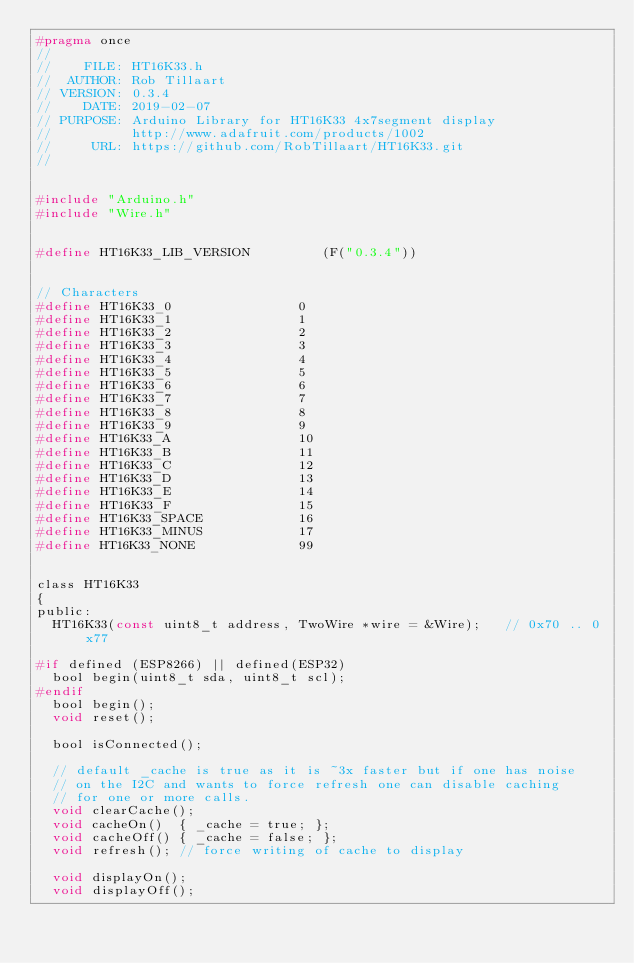Convert code to text. <code><loc_0><loc_0><loc_500><loc_500><_C_>#pragma once
//
//    FILE: HT16K33.h
//  AUTHOR: Rob Tillaart
// VERSION: 0.3.4
//    DATE: 2019-02-07
// PURPOSE: Arduino Library for HT16K33 4x7segment display
//          http://www.adafruit.com/products/1002
//     URL: https://github.com/RobTillaart/HT16K33.git
//


#include "Arduino.h"
#include "Wire.h"


#define HT16K33_LIB_VERSION         (F("0.3.4"))


// Characters
#define HT16K33_0                0
#define HT16K33_1                1
#define HT16K33_2                2
#define HT16K33_3                3
#define HT16K33_4                4
#define HT16K33_5                5
#define HT16K33_6                6
#define HT16K33_7                7
#define HT16K33_8                8
#define HT16K33_9                9
#define HT16K33_A                10
#define HT16K33_B                11
#define HT16K33_C                12
#define HT16K33_D                13
#define HT16K33_E                14
#define HT16K33_F                15
#define HT16K33_SPACE            16
#define HT16K33_MINUS            17
#define HT16K33_NONE             99


class HT16K33
{
public:
  HT16K33(const uint8_t address, TwoWire *wire = &Wire);   // 0x70 .. 0x77

#if defined (ESP8266) || defined(ESP32)
  bool begin(uint8_t sda, uint8_t scl);
#endif
  bool begin();
  void reset();

  bool isConnected();

  // default _cache is true as it is ~3x faster but if one has noise
  // on the I2C and wants to force refresh one can disable caching
  // for one or more calls.
  void clearCache();
  void cacheOn()  { _cache = true; };
  void cacheOff() { _cache = false; };
  void refresh(); // force writing of cache to display

  void displayOn();
  void displayOff();
</code> 